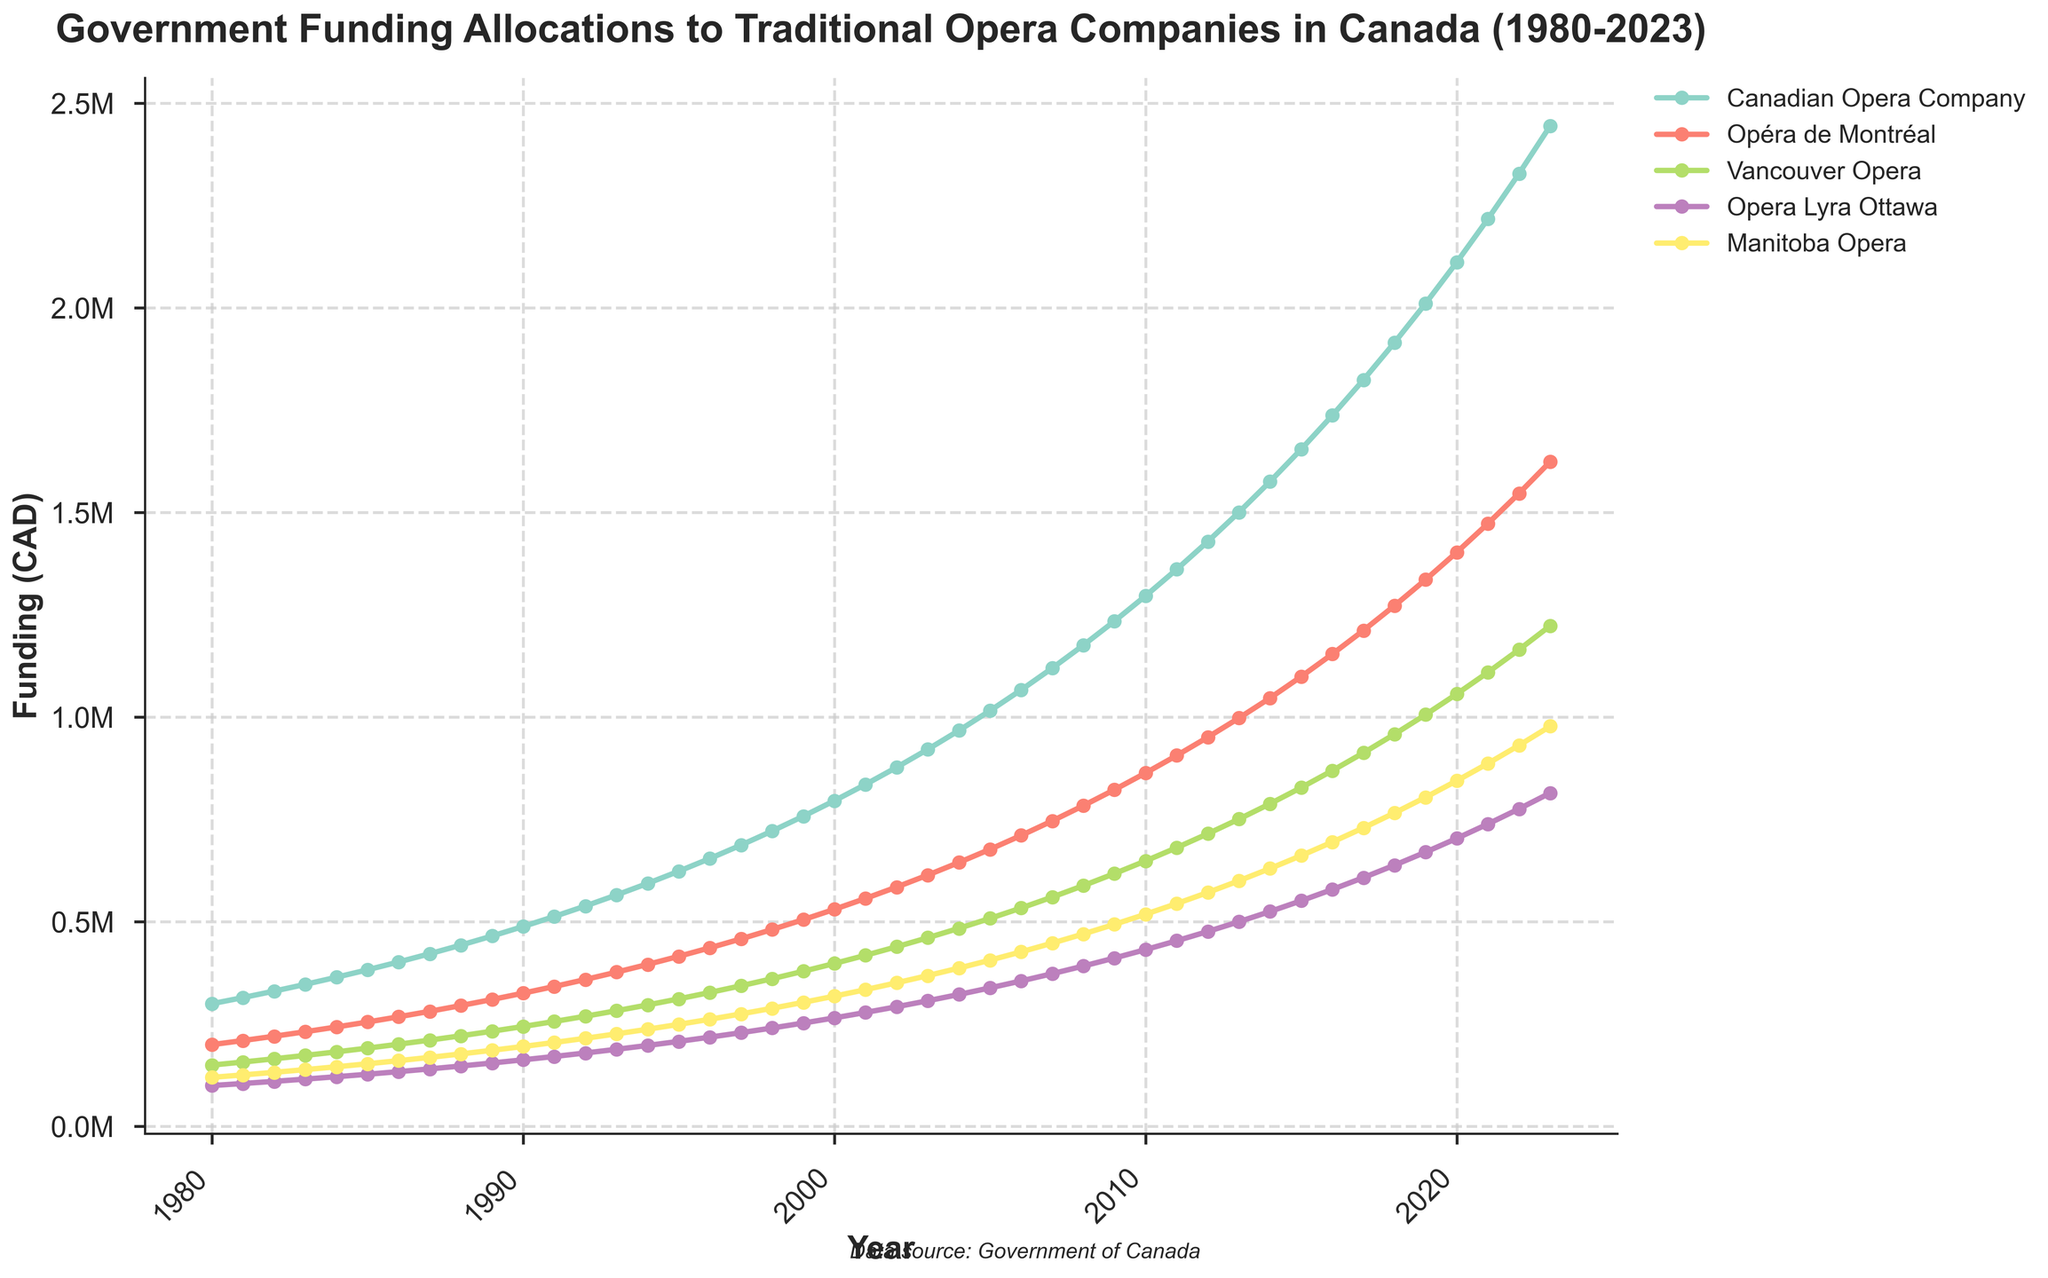What is the highest funding allocation in the figure? To find the highest funding allocation, locate the maximum point across all the lines on the y-axis, which represents the funding. By inspecting, the highest point is for the Canadian Opera Company in 2023, which is 2,444,948 CAD.
Answer: 2,444,948 CAD Which opera company shows the most consistent increase in funding from 1980 to 2023? Consistent increase implies a steadily upward trend without significant dips. By observing all lines, the Canadian Opera Company shows a consistent increase in funding without noticeable fluctuations.
Answer: Canadian Opera Company What is the approximate funding difference between the Canadian Opera Company and Opéra de Montréal in 2023? Locate their funding values in 2023: Canadian Opera Company is 2,444,948 CAD, and Opéra de Montréal is 1,624,358 CAD. Subtract the latter from the former: 2,444,948 - 1,624,358 = 820,590 CAD.
Answer: 820,590 CAD During which decade did the Vancouver Opera see the steepest increase in funding? With time on the x-axis and funding on the y-axis, observe the slope of the Vancouver Opera line over different decades. The steepest slope appears in the 2000s, suggesting the highest funding increase during this period.
Answer: 2000s What is the median funding for Opera Lyra Ottawa in the given time range? Median is the middle value when they are ordered. List Opera Lyra Ottawa's funding from 1980 to 2023 and find the middle value. The sorted series is: 100,000, 105,000, 110,250, ..., 814,950. With 44 data points, the median is the average of the 22nd and 23rd values, i.e., (292,522 + 307,148)/2 = 299,835 CAD.
Answer: 299,835 CAD Which year did the Manitoba Opera funding cross the 500,000 CAD mark? Trace Manitoba Opera's plot line and locate the first year it surpasses 500,000 CAD. It crosses 500,000 CAD in the year 2009.
Answer: 2009 How many unique funding levels are shown for the Canadian Opera Company? Count the number of distinct y-values along the Canadian Opera Company line. Each year has a unique value, from 1980 to 2023, giving 44 unique funding levels.
Answer: 44 In which year did Opéra de Montréal show the largest year-over-year increase in funding? Compare yearly funding differences for Opéra de Montréal. The largest increase is from 2021 (1,473,341 CAD) to 2022 (1,547,008 CAD), with a difference of 73,667 CAD.
Answer: 2022 What was the average annual funding for Vancouver Opera during the 1990s? List Vancouver Opera funding from 1990 to 1999, sum these values, and divide by 10: (244,333 + 256,550 + 269,378 + ... + 379,211) / 10 = 292,569 CAD.
Answer: 292,569 CAD How does the growth rate of funding for Manitoba Opera compare to Opera Lyra Ottawa between 1980 and 2023? Calculate the growth for Manitoba Opera: (977,964 - 120,000) / 120,000 = 7.15. For Opera Lyra Ottawa: (814,950 - 100,000) / 100,000 = 7.15. Both operas have the same growth rate of 7.15.
Answer: Same growth rate 